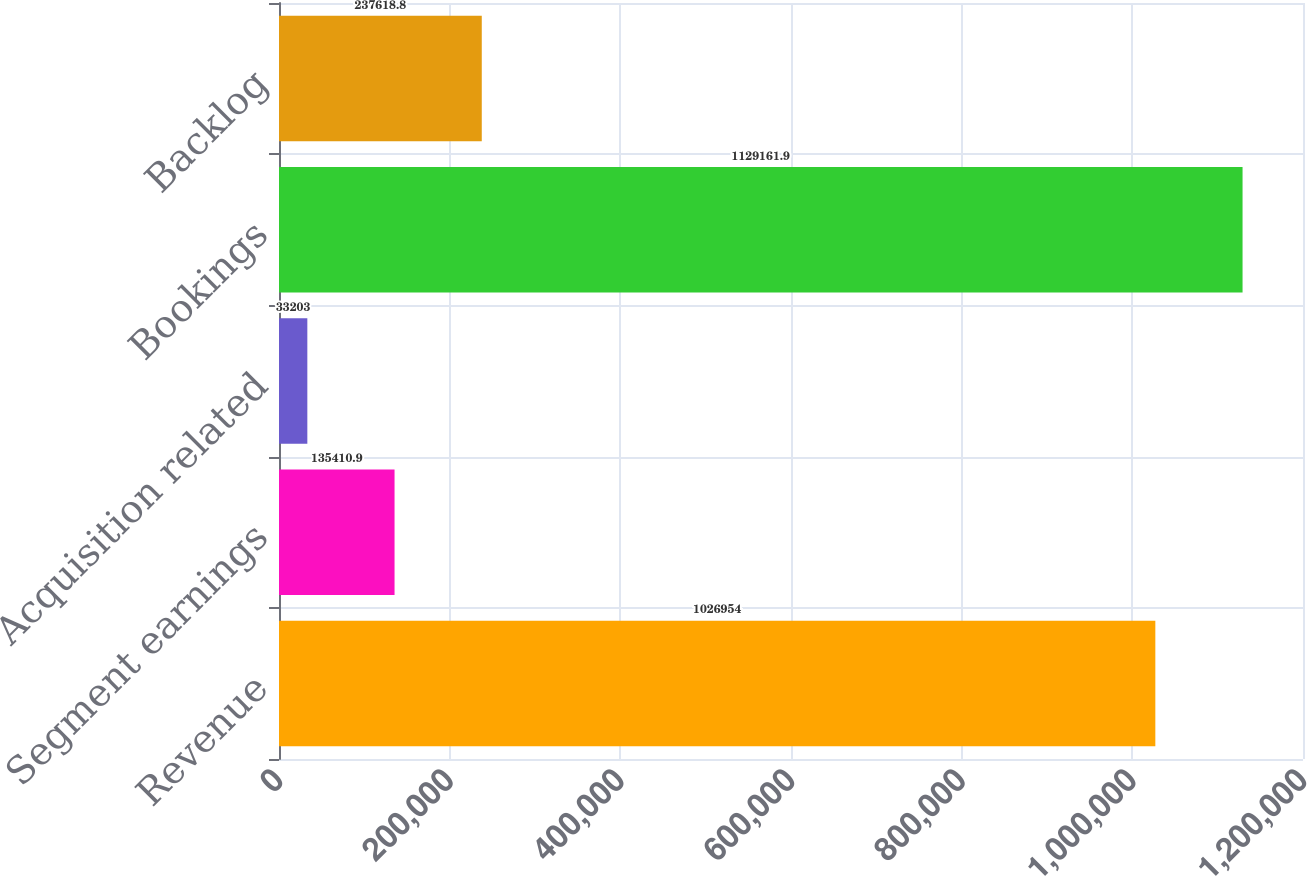<chart> <loc_0><loc_0><loc_500><loc_500><bar_chart><fcel>Revenue<fcel>Segment earnings<fcel>Acquisition related<fcel>Bookings<fcel>Backlog<nl><fcel>1.02695e+06<fcel>135411<fcel>33203<fcel>1.12916e+06<fcel>237619<nl></chart> 